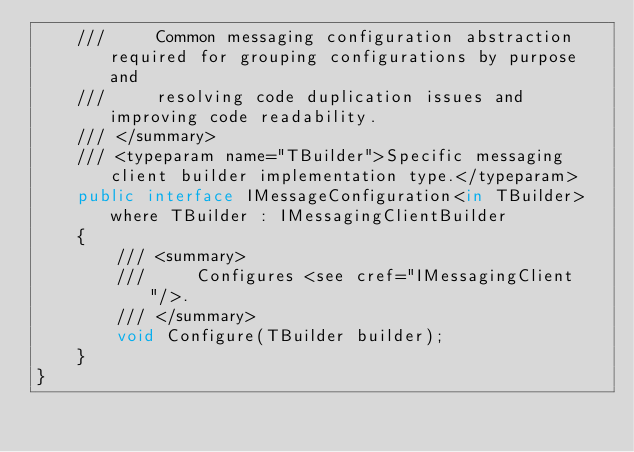Convert code to text. <code><loc_0><loc_0><loc_500><loc_500><_C#_>    ///     Common messaging configuration abstraction required for grouping configurations by purpose and
    ///     resolving code duplication issues and improving code readability.
    /// </summary>
    /// <typeparam name="TBuilder">Specific messaging client builder implementation type.</typeparam>
    public interface IMessageConfiguration<in TBuilder> where TBuilder : IMessagingClientBuilder
    {
        /// <summary>
        ///     Configures <see cref="IMessagingClient"/>.
        /// </summary>
        void Configure(TBuilder builder);
    }
}
</code> 